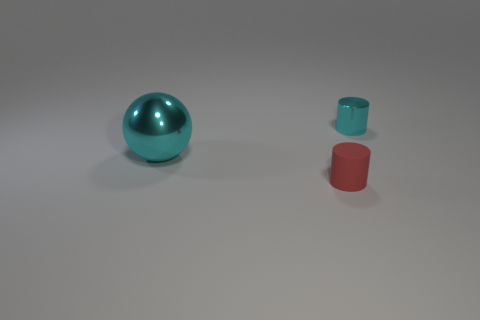What is the shape of the shiny object that is left of the metal thing that is on the right side of the tiny object that is in front of the big object?
Your response must be concise. Sphere. What is the shape of the cyan metallic object in front of the cyan thing to the right of the big shiny thing?
Your response must be concise. Sphere. Are there any small cyan things that have the same material as the big cyan object?
Ensure brevity in your answer.  Yes. There is a cylinder that is the same color as the big shiny sphere; what is its size?
Your answer should be very brief. Small. How many cyan objects are big metal spheres or rubber cylinders?
Keep it short and to the point. 1. Are there any big shiny objects of the same color as the small metallic cylinder?
Give a very brief answer. Yes. There is a object that is the same material as the cyan ball; what is its size?
Your answer should be very brief. Small. How many cylinders are either shiny things or rubber things?
Your response must be concise. 2. Is the number of cyan metallic cylinders greater than the number of metallic objects?
Make the answer very short. No. What number of cyan metallic cylinders are the same size as the red matte cylinder?
Provide a short and direct response. 1. 